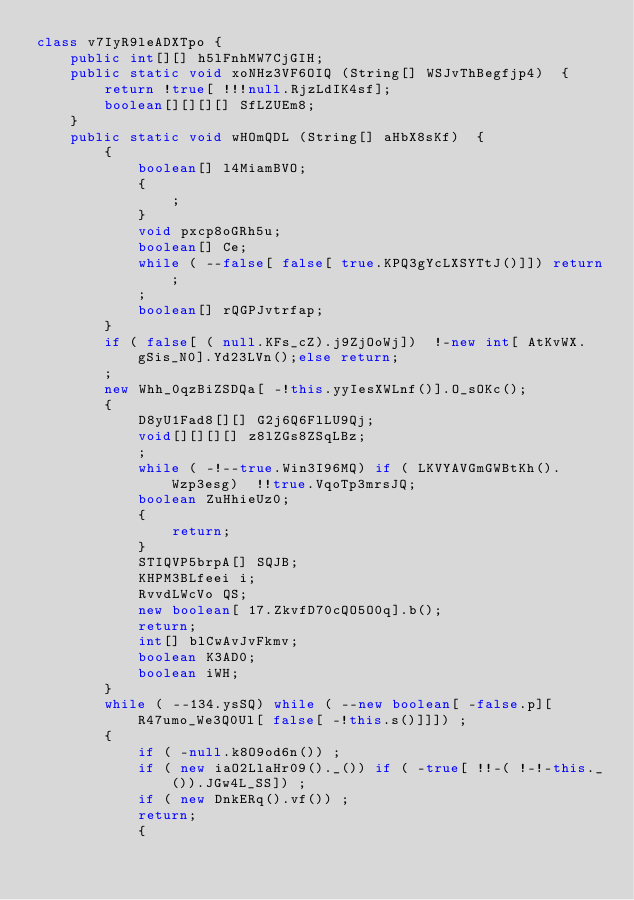<code> <loc_0><loc_0><loc_500><loc_500><_Java_>class v7IyR9leADXTpo {
    public int[][] h5lFnhMW7CjGIH;
    public static void xoNHz3VF6OIQ (String[] WSJvThBegfjp4)  {
        return !true[ !!!null.RjzLdIK4sf];
        boolean[][][][] SfLZUEm8;
    }
    public static void wHOmQDL (String[] aHbX8sKf)  {
        {
            boolean[] l4MiamBVO;
            {
                ;
            }
            void pxcp8oGRh5u;
            boolean[] Ce;
            while ( --false[ false[ true.KPQ3gYcLXSYTtJ()]]) return;
            ;
            boolean[] rQGPJvtrfap;
        }
        if ( false[ ( null.KFs_cZ).j9ZjOoWj])  !-new int[ AtKvWX.gSis_N0].Yd23LVn();else return;
        ;
        new Whh_0qzBiZSDQa[ -!this.yyIesXWLnf()].O_sOKc();
        {
            D8yU1Fad8[][] G2j6Q6FlLU9Qj;
            void[][][][] z8lZGs8ZSqLBz;
            ;
            while ( -!--true.Win3I96MQ) if ( LKVYAVGmGWBtKh().Wzp3esg)  !!true.VqoTp3mrsJQ;
            boolean ZuHhieUz0;
            {
                return;
            }
            STIQVP5brpA[] SQJB;
            KHPM3BLfeei i;
            RvvdLWcVo QS;
            new boolean[ 17.ZkvfD70cQO5O0q].b();
            return;
            int[] blCwAvJvFkmv;
            boolean K3AD0;
            boolean iWH;
        }
        while ( --134.ysSQ) while ( --new boolean[ -false.p][ R47umo_We3Q0Ul[ false[ -!this.s()]]]) ;
        {
            if ( -null.k8O9od6n()) ;
            if ( new iaO2LlaHr09()._()) if ( -true[ !!-( !-!-this._()).JGw4L_SS]) ;
            if ( new DnkERq().vf()) ;
            return;
            {</code> 